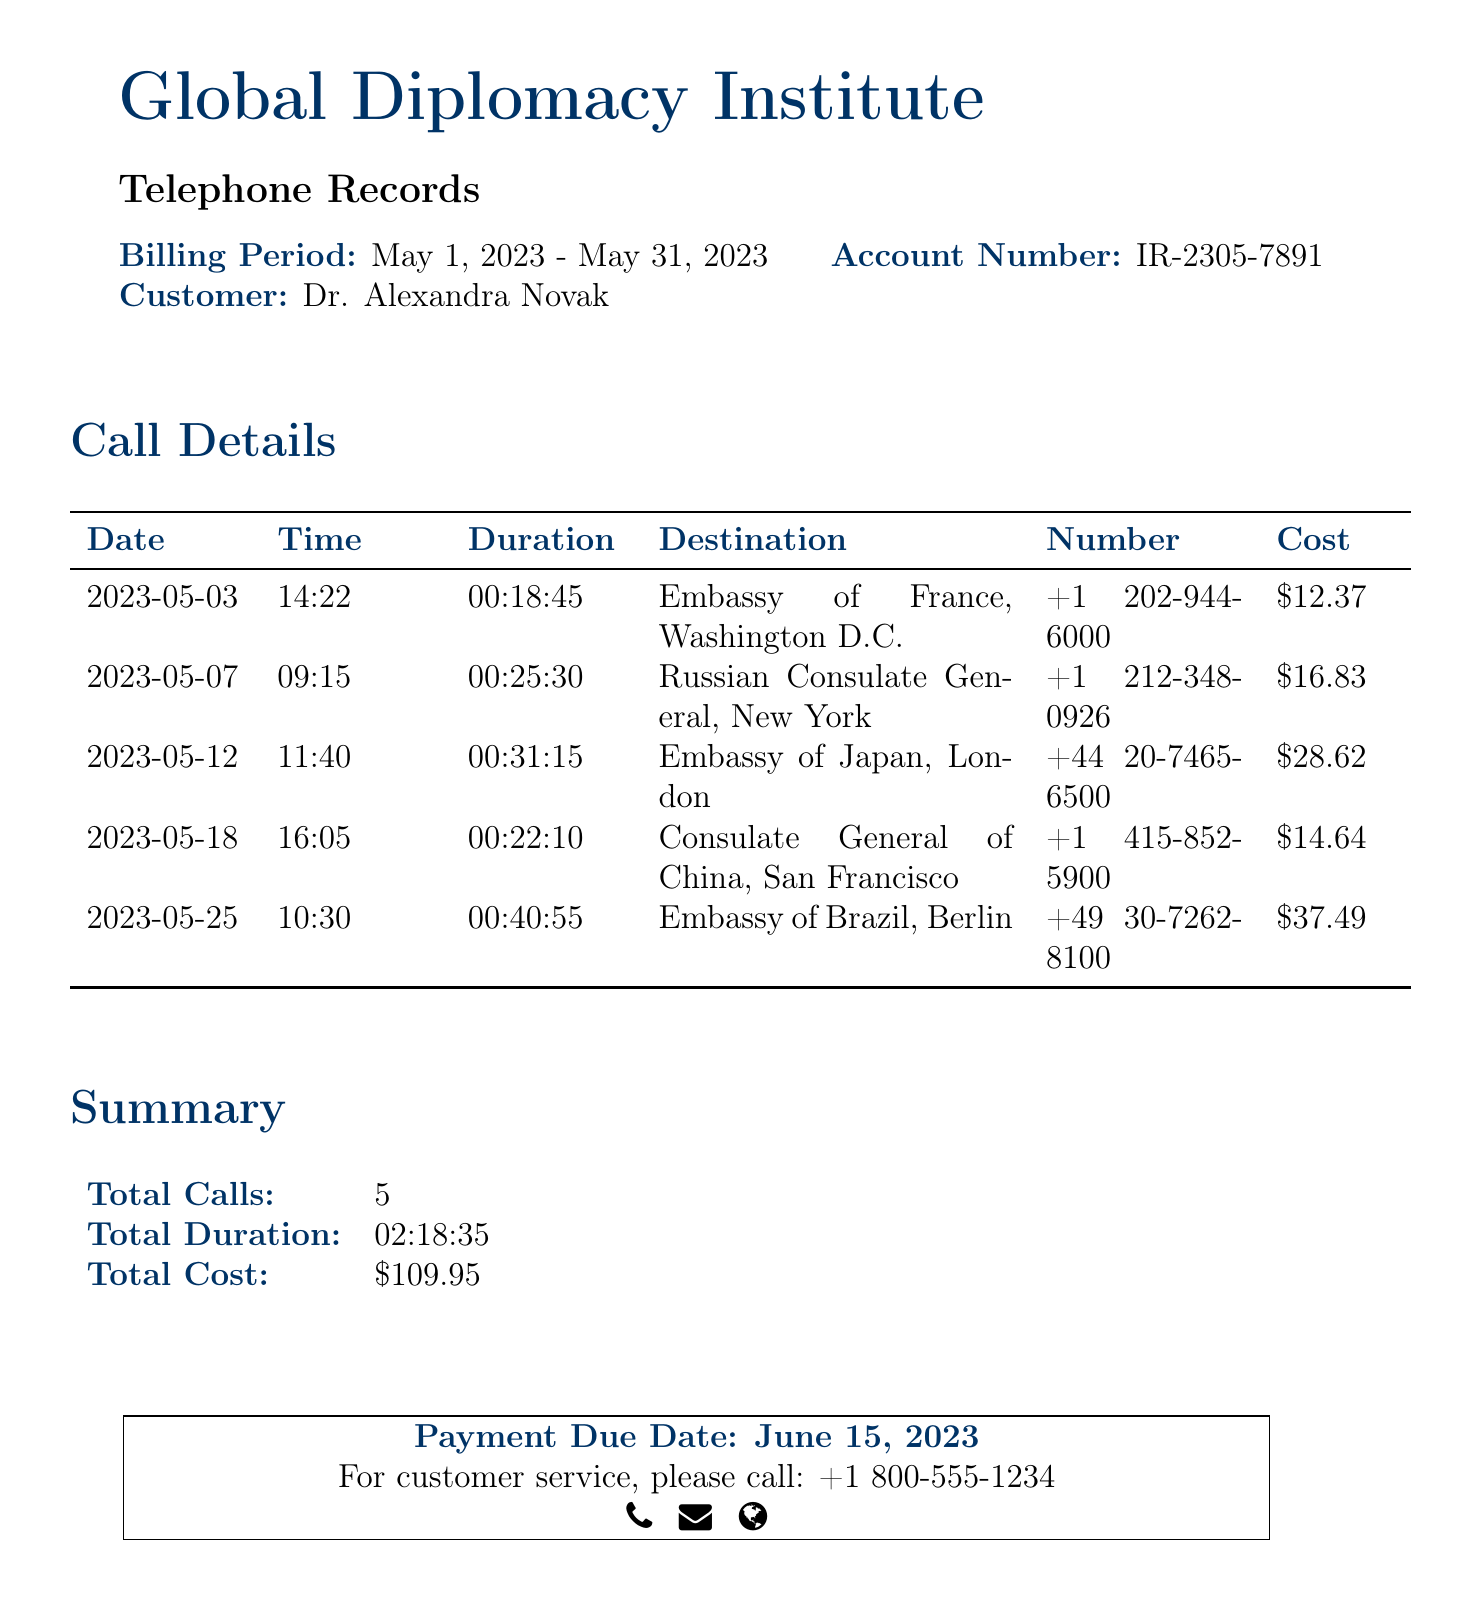What is the billing period? The billing period is specified in the document as May 1, 2023 - May 31, 2023.
Answer: May 1, 2023 - May 31, 2023 Who is the customer? The document states that the customer is Dr. Alexandra Novak.
Answer: Dr. Alexandra Novak What was the total cost of calls? The total cost is provided in the summary section of the document, which amounts to $109.95.
Answer: $109.95 How many calls were made? The number of calls listed in the summary is five.
Answer: 5 What was the duration of the longest call? By examining the call details, the longest call lasted 00:40:55 to the Embassy of Brazil.
Answer: 00:40:55 Which embassy was called on May 12, 2023? The call details specify that on this date, the Embassy of Japan in London was contacted.
Answer: Embassy of Japan, London What is the payment due date? The document indicates that the payment due date is June 15, 2023.
Answer: June 15, 2023 What is the cost of the call to the Russian Consulate? The cost for the call to the Russian Consulate General is $16.83 as per the call details.
Answer: $16.83 How many calls were made to consulates? Looking at the call details, there were two calls made to consulates: one to China and one to Russia.
Answer: 2 